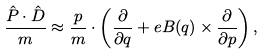<formula> <loc_0><loc_0><loc_500><loc_500>\frac { \hat { P } \cdot \hat { D } } { m } \approx \frac { p } { m } \cdot \left ( \frac { \partial } { \partial q } + e B ( q ) \times \frac { \partial } { \partial p } \right ) ,</formula> 